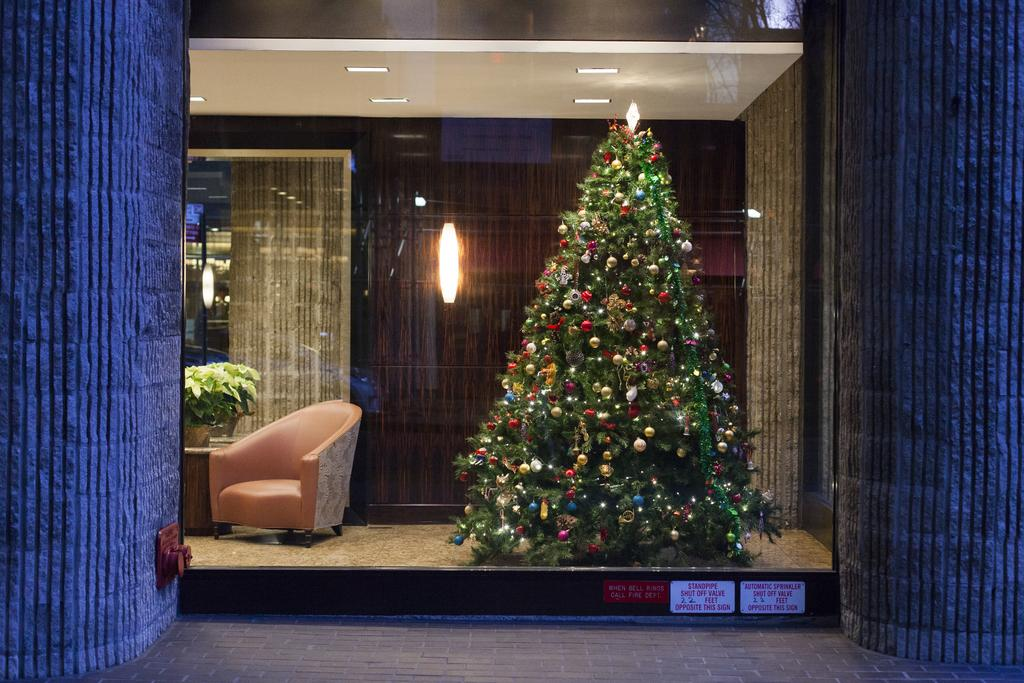What type of building can be seen in the picture? There is a house in the picture. What is inside the house that is visible in the picture? Inside the house, there is a Christmas tree. What is located beside the Christmas tree? A chair is present beside the Christmas tree. What type of vegetation is present in the room? There is a plant in the room. What type of lighting is visible in the room? Lights are visible in the room, including lights on the ceiling. What type of reflective surface is present in the room? A mirror is present in the room. How many cows are visible in the room? There are no cows present in the room; the image features a house with a Christmas tree, chair, plant, lights, and a mirror. 